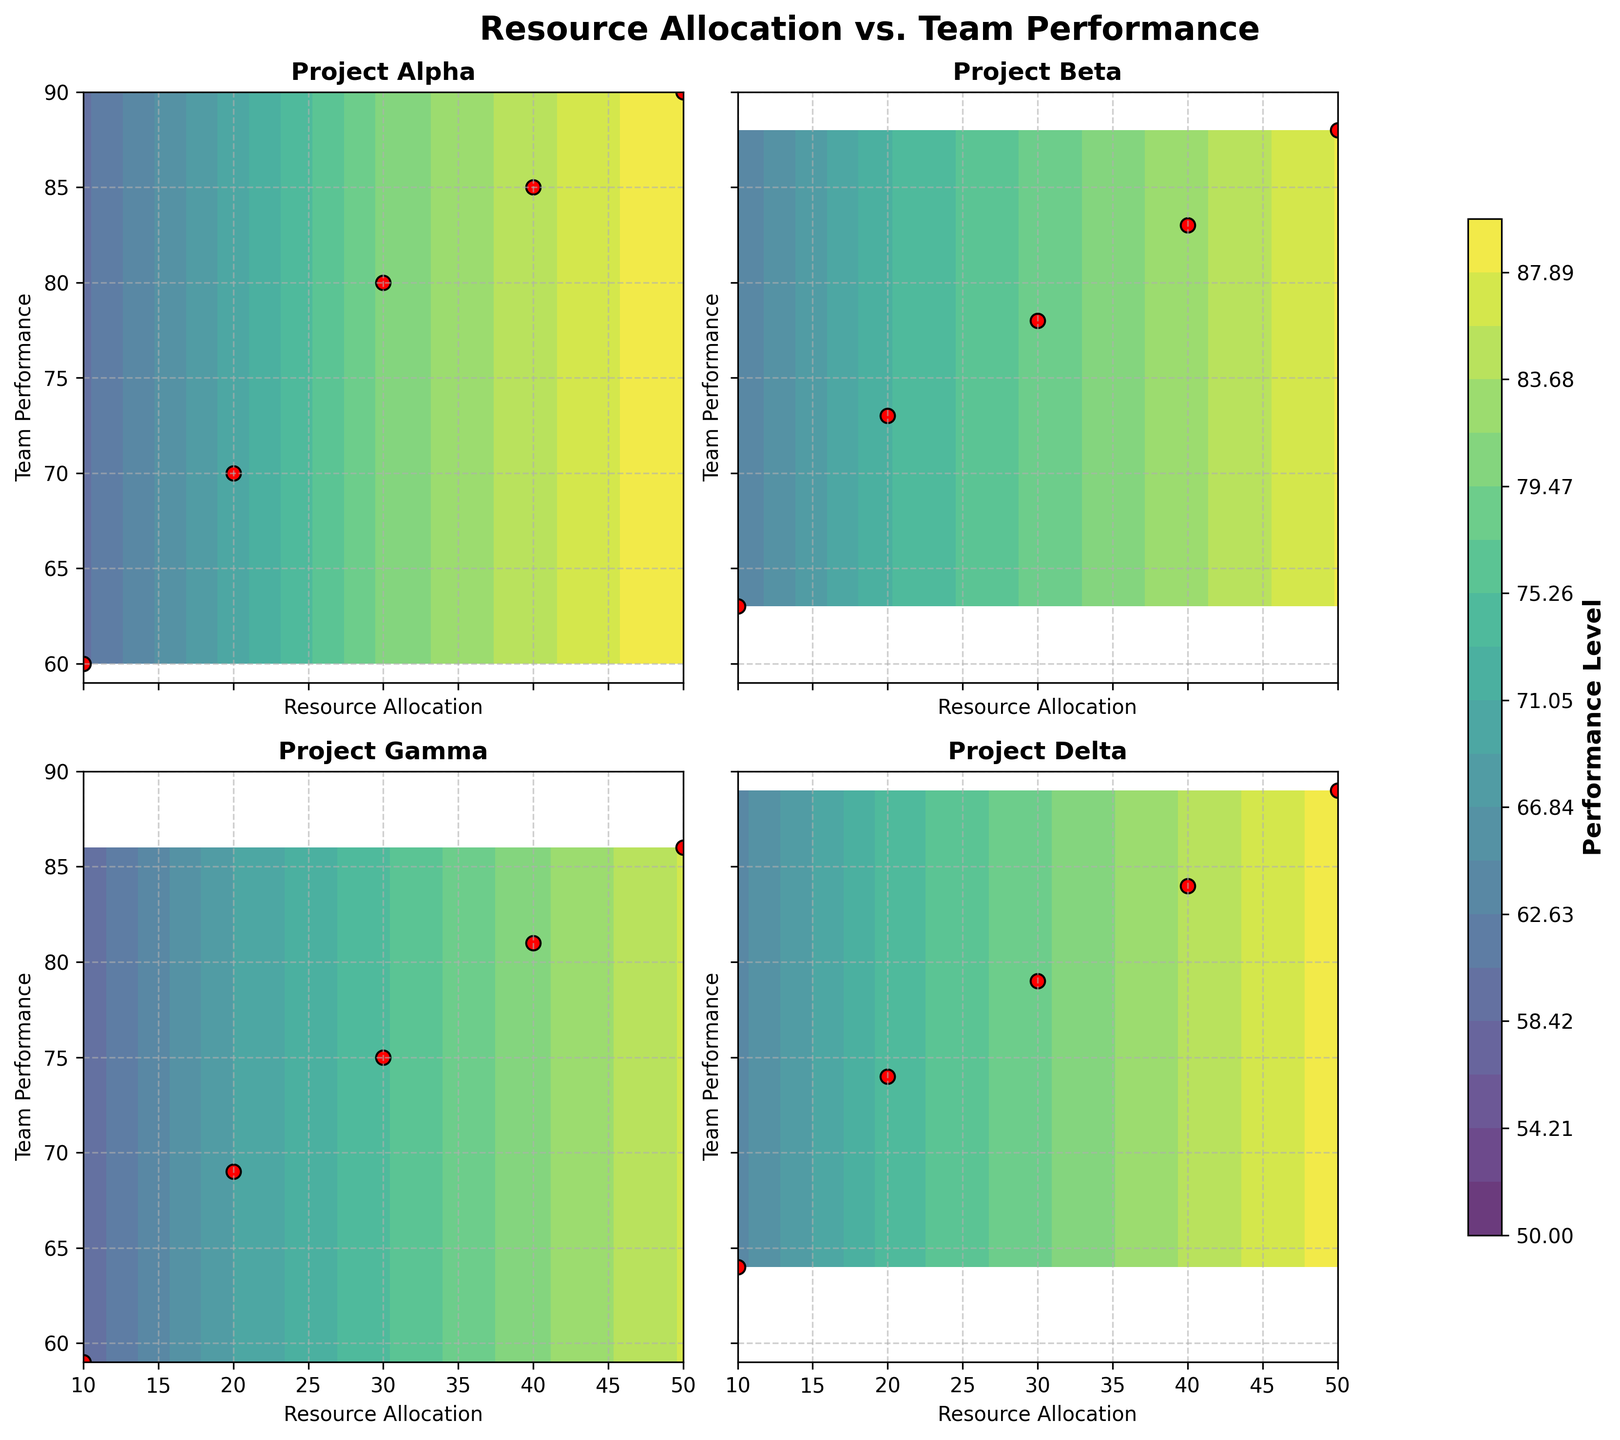What's the title of the figure? The figure's title is prominently displayed at the top, indicating the overall theme being analyzed.
Answer: Resource Allocation vs. Team Performance How many subplots are there in the figure? The figure displays a 2x2 grid, showing 4 distinct subplots.
Answer: 4 What is the range of performance levels represented in the color bar? The color bar indicates the gradient of performance levels displayed in the contour plots. The levels range from 50 to 90.
Answer: 50 to 90 Which project shows the highest team performance at the lowest resource allocation? By examining each subplot at the lowest resource allocation (10 units), we find that Project Delta has the highest team performance of 64.
Answer: Project Delta Which project demonstrates the most gradual increase in performance as resources increase? By comparing the slope of performance increase in each subplot, Project Gamma shows the most gradual increase from 59 to 86 as resources go from 10 to 50.
Answer: Project Gamma How does the performance of Project Alpha at 30 units of resource allocation compare to the performance of Project Beta at the same resource level? Project Alpha's performance at 30 units is 80. Project Beta's performance at 30 units is 78. Therefore, Project Alpha performs better.
Answer: Project Alpha performs better What is the resource allocation for Project Beta when team performance is 73? In the subplot for Project Beta, the performance level of 73 corresponds to a resource allocation of 20 units.
Answer: 20 units Which two projects have the closest team performance at 50 units of resource allocation? By checking the performance levels at 50 units, Projects Alpha (90) and Delta (89) have the closest performance levels.
Answer: Projects Alpha and Delta What is the average performance of Project Gamma across all levels of resource allocation? Summing the performance values (59, 69, 75, 81, 86) and dividing by the number of points (5): (59+69+75+81+86)/5 = 370/5, we get an average performance of 74.
Answer: 74 Which project exhibits the highest overall improvement in team performance as resource allocation increases from 10 to 50 units? The improvement for each project is calculated as the difference between performance at 50 units and at 10 units. Alpha: 90-60=30, Beta: 88-63=25, Gamma: 86-59=27, Delta: 89-64=25. Project Alpha shows the highest improvement with an increase of 30.
Answer: Project Alpha 